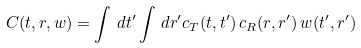Convert formula to latex. <formula><loc_0><loc_0><loc_500><loc_500>C ( t , r , w ) = \int \, d t ^ { \prime } \int \, d r ^ { \prime } c _ { T } ( t , t ^ { \prime } ) \, c _ { R } ( r , r ^ { \prime } ) \, w ( t ^ { \prime } , r ^ { \prime } )</formula> 